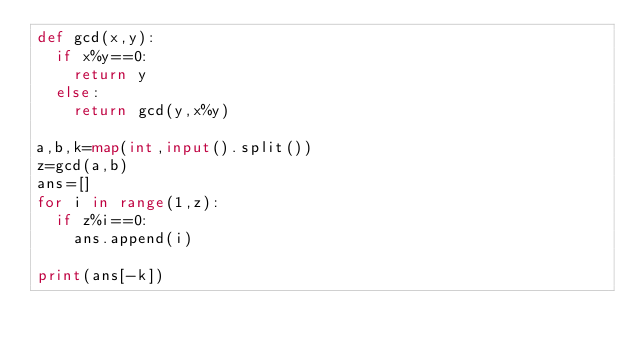<code> <loc_0><loc_0><loc_500><loc_500><_Python_>def gcd(x,y):
  if x%y==0:
    return y
  else:
    return gcd(y,x%y)

a,b,k=map(int,input().split())
z=gcd(a,b)
ans=[]
for i in range(1,z):
  if z%i==0:
    ans.append(i)
    
print(ans[-k])  
    </code> 